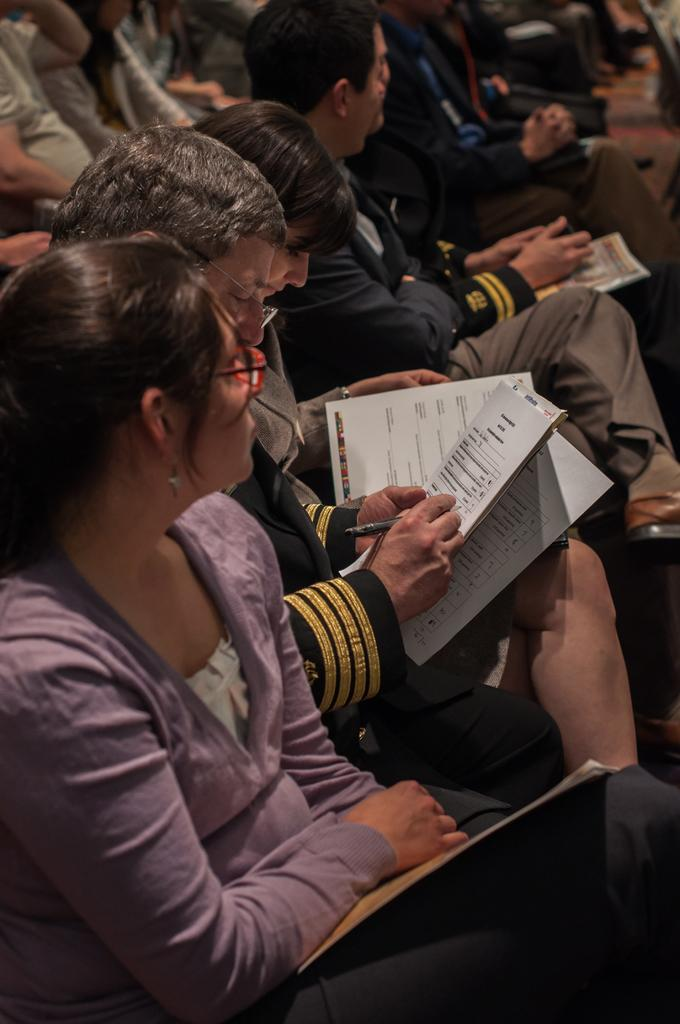What types of people are present in the image? There are men and women in the image. What are the men and women doing in the image? The men and women are sitting. What are the men and women holding in their hands? The men and women are holding papers in their hands. What type of soup is being served to the men and women in the image? There is no soup present in the image; the men and women are holding papers in their hands. 